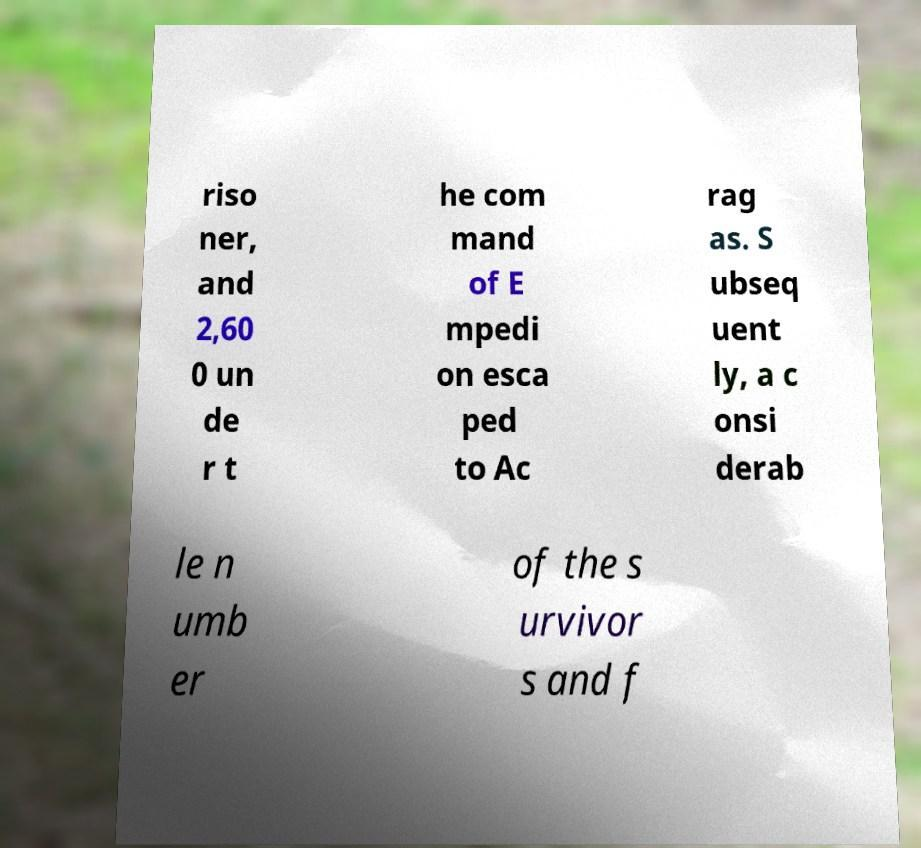Please read and relay the text visible in this image. What does it say? riso ner, and 2,60 0 un de r t he com mand of E mpedi on esca ped to Ac rag as. S ubseq uent ly, a c onsi derab le n umb er of the s urvivor s and f 